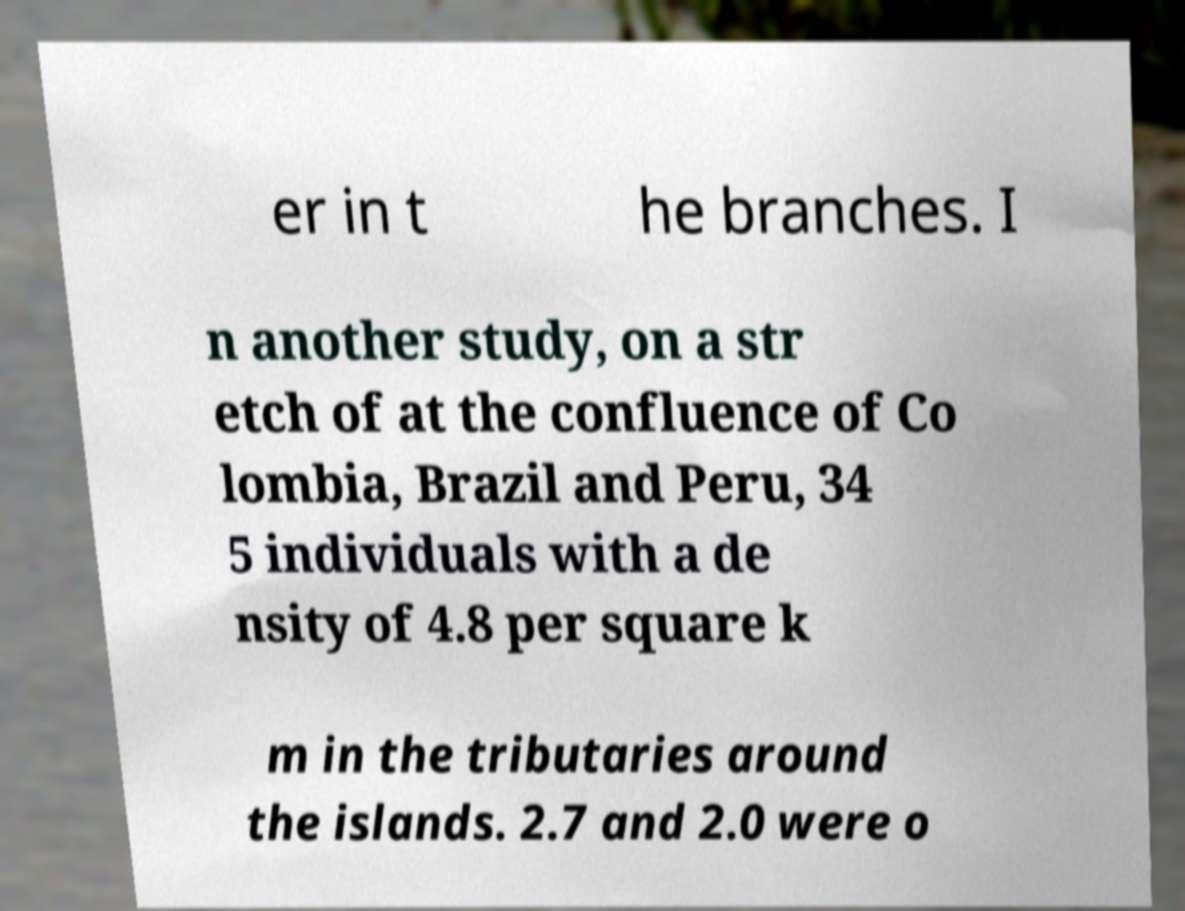Could you extract and type out the text from this image? er in t he branches. I n another study, on a str etch of at the confluence of Co lombia, Brazil and Peru, 34 5 individuals with a de nsity of 4.8 per square k m in the tributaries around the islands. 2.7 and 2.0 were o 